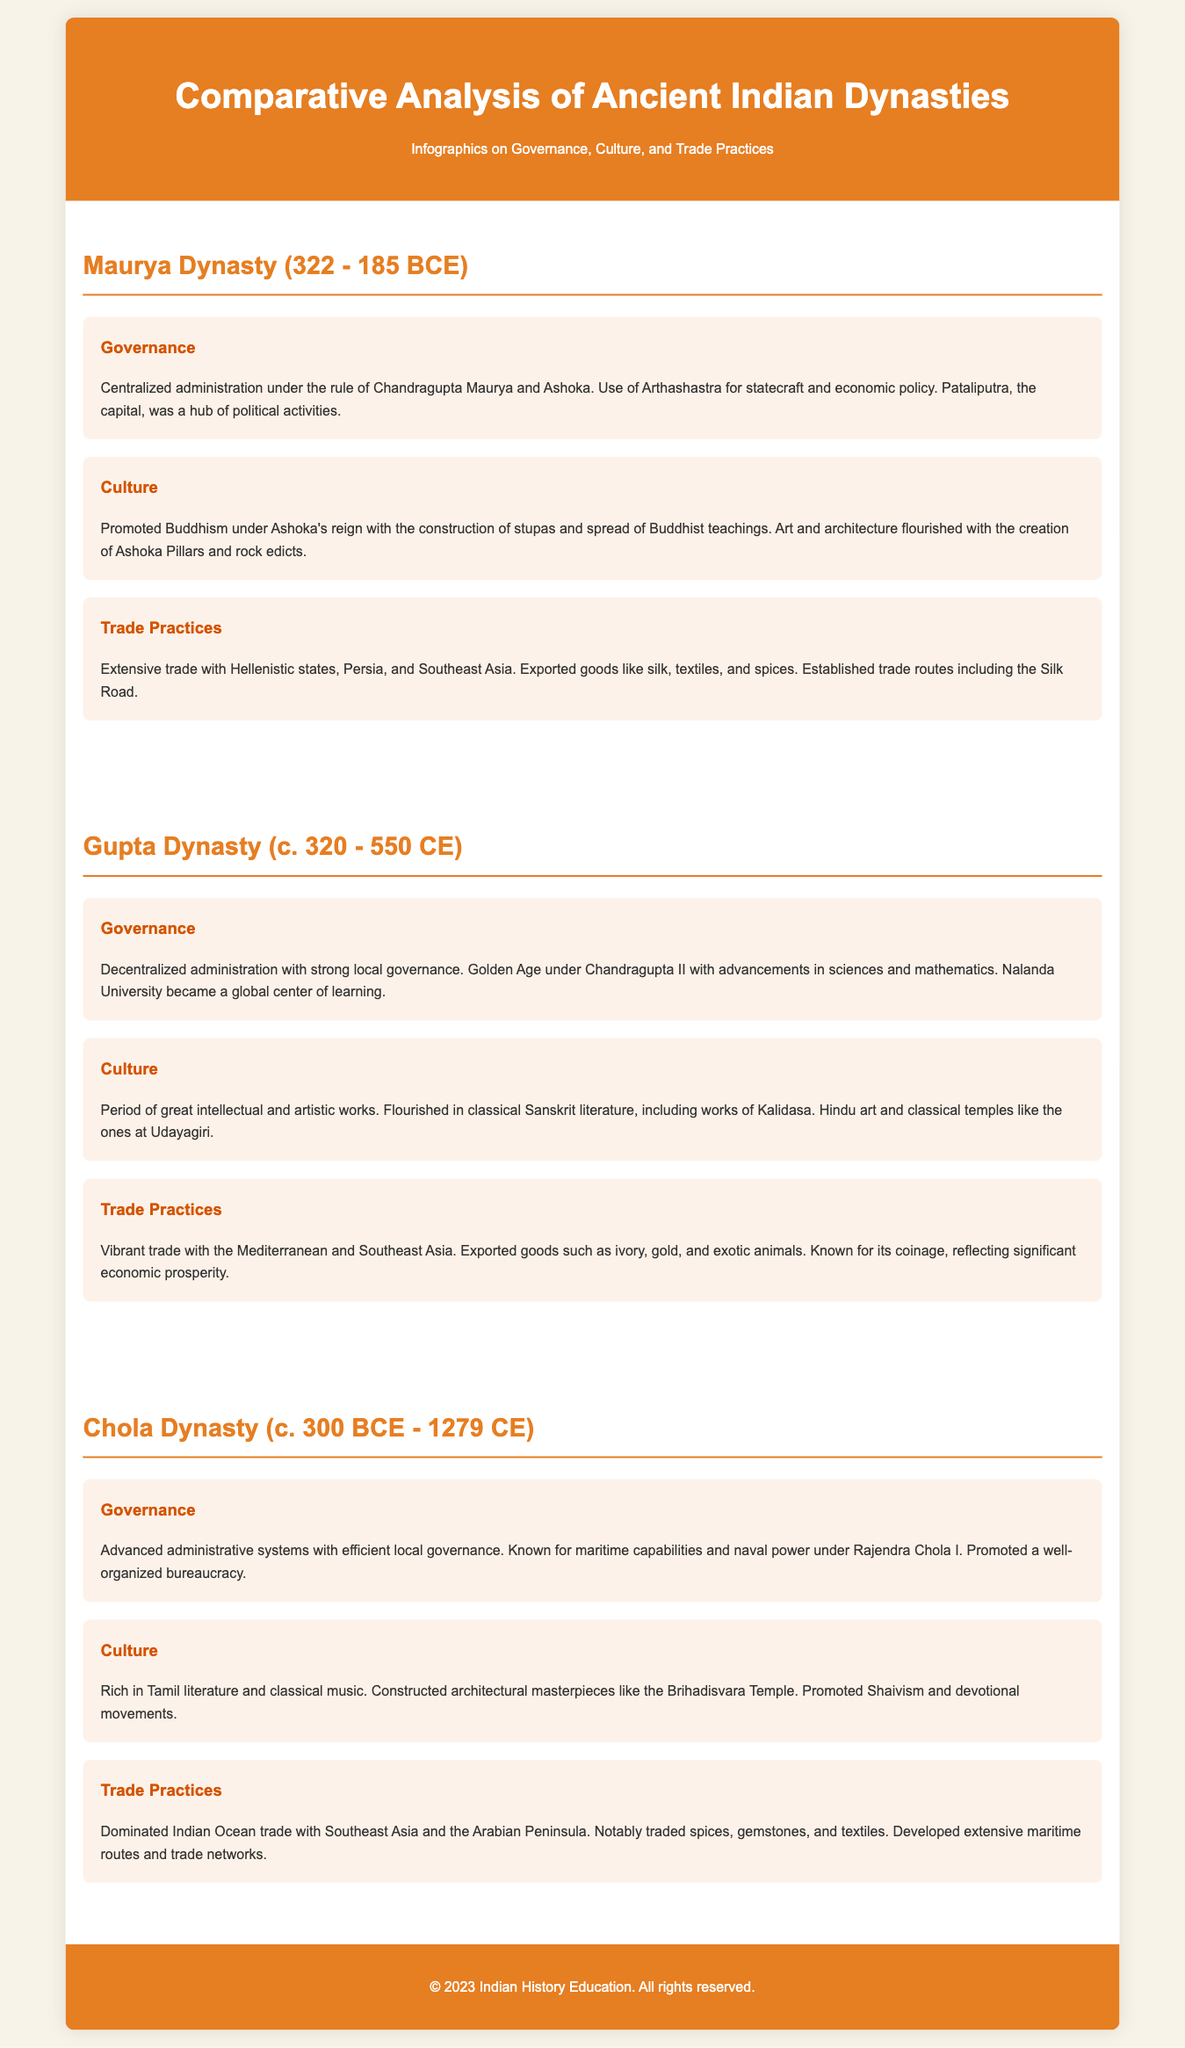What was the capital of the Maurya Dynasty? The document states that Pataliputra was the capital of the Maurya Dynasty, which was a hub of political activities.
Answer: Pataliputra What period is known as the Golden Age of the Gupta Dynasty? The document refers to the Golden Age occurring under Chandragupta II, specifically during the time frame of c. 320 - 550 CE.
Answer: c. 320 - 550 CE Which dynasty is known for its maritime capabilities? The document highlights the Chola Dynasty being known for its maritime capabilities and naval power under Rajendra Chola I.
Answer: Chola Dynasty What significant educational institution was established during the Gupta Dynasty? The text mentions that Nalanda University became a global center of learning during the Gupta Dynasty.
Answer: Nalanda University Which practice flourished significantly under Ashoka's reign? The document specifies that Buddhism was promoted under Ashoka's reign with the construction of stupas and spread of teachings.
Answer: Buddhism What type of literature flourished during the Gupta Dynasty? The document mentions that classical Sanskrit literature, including works of Kalidasa, flourished during the Gupta Dynasty.
Answer: Classical Sanskrit literature What goods were extensively traded by the Maurya Dynasty? The document states that the Maurya Dynasty exported goods like silk, textiles, and spices.
Answer: Silk, textiles, and spices Which temple is noted as an architectural masterpiece of the Chola Dynasty? The document refers to the Brihadisvara Temple as a significant architectural masterpiece built by the Chola Dynasty.
Answer: Brihadisvara Temple What is an infographic about in the context of this document? The document presents infographics regarding Governance, Culture, and Trade Practices of the ancient Indian dynasties.
Answer: Governance, Culture, and Trade Practices 